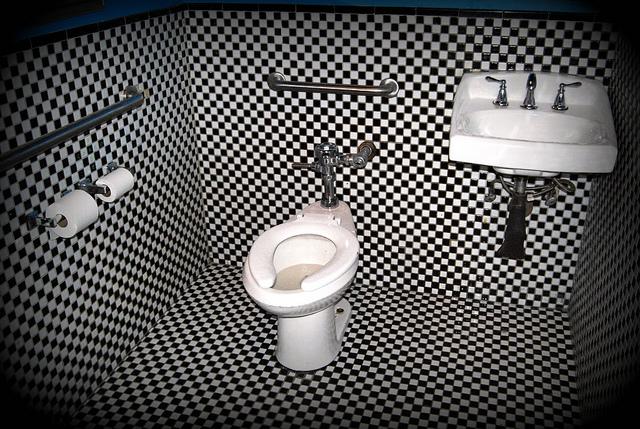Can you cook in this room?
Short answer required. No. How many rolls of toilet paper are there?
Concise answer only. 2. What is the darkest color in this room?
Be succinct. Black. 